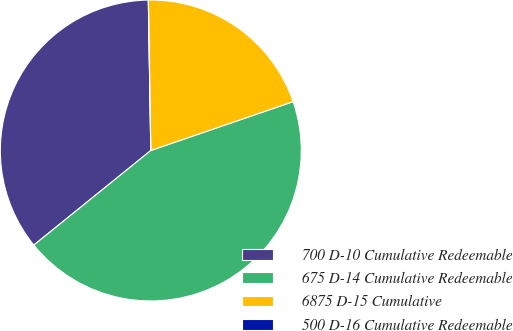Convert chart. <chart><loc_0><loc_0><loc_500><loc_500><pie_chart><fcel>700 D-10 Cumulative Redeemable<fcel>675 D-14 Cumulative Redeemable<fcel>6875 D-15 Cumulative<fcel>500 D-16 Cumulative Redeemable<nl><fcel>35.56%<fcel>44.44%<fcel>20.0%<fcel>0.0%<nl></chart> 